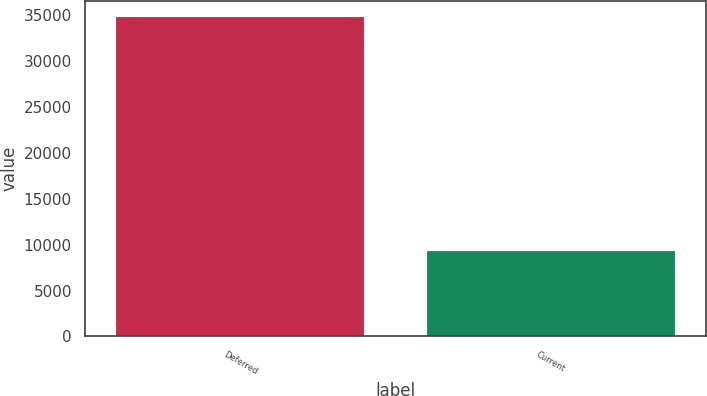Convert chart to OTSL. <chart><loc_0><loc_0><loc_500><loc_500><bar_chart><fcel>Deferred<fcel>Current<nl><fcel>34813<fcel>9310<nl></chart> 